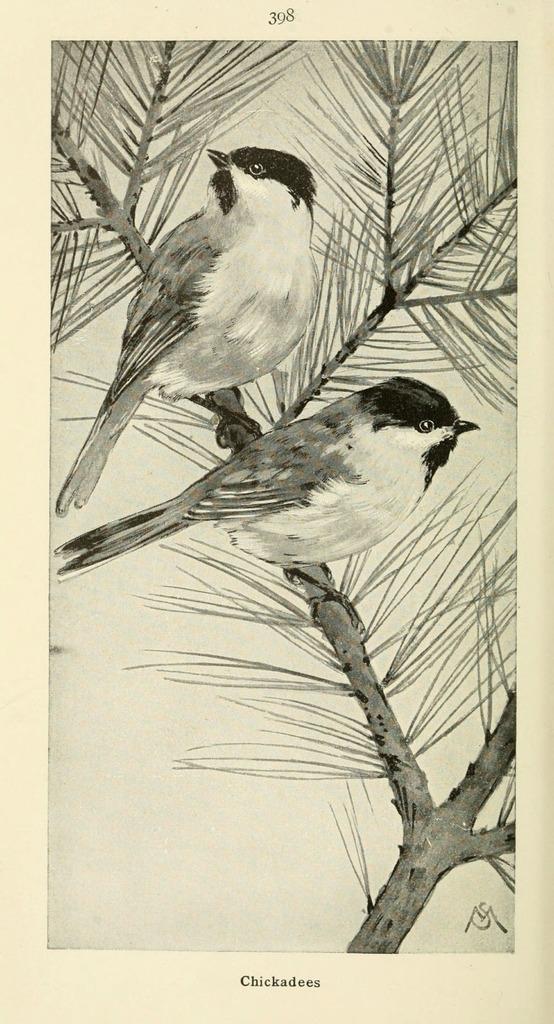How would you summarize this image in a sentence or two? This is a drawing, in this image in the center there are two birds on a tree, and there is a white background. At the top and bottom of the image there is text. 